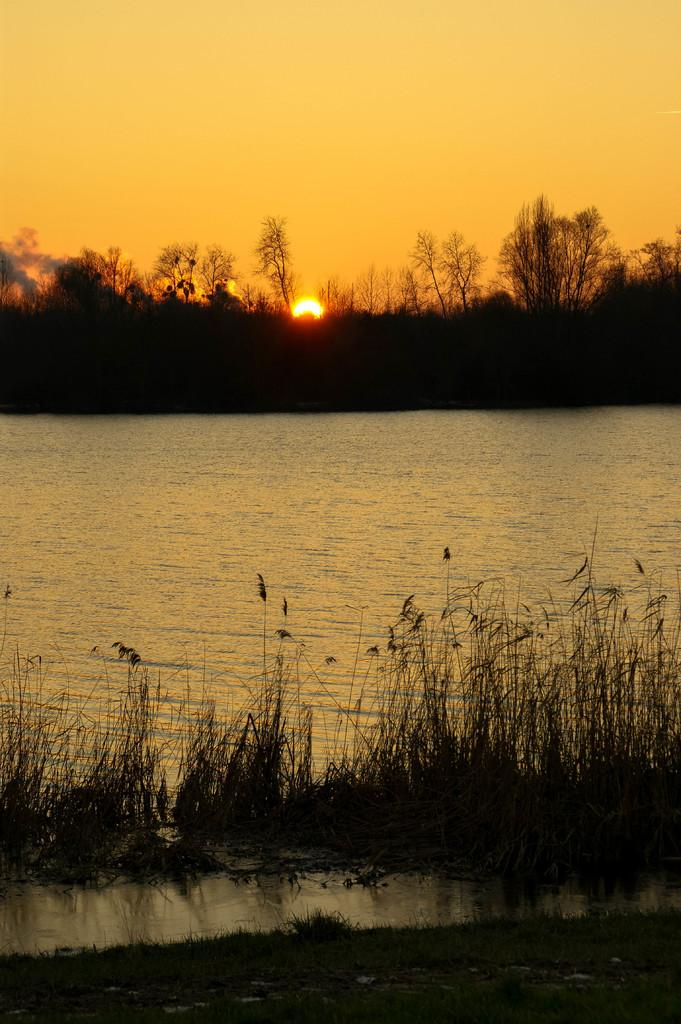What is located in the middle of the image? There is water in the middle of the image. What can be seen in the background of the image? There are trees in the background of the image. What is visible at the top of the image? The sky is visible at the top of the image. How many fingers can be seen in the image? There are no fingers visible in the image. What type of car is parked near the water in the image? There is no car present in the image; it only features water, trees, and the sky. 